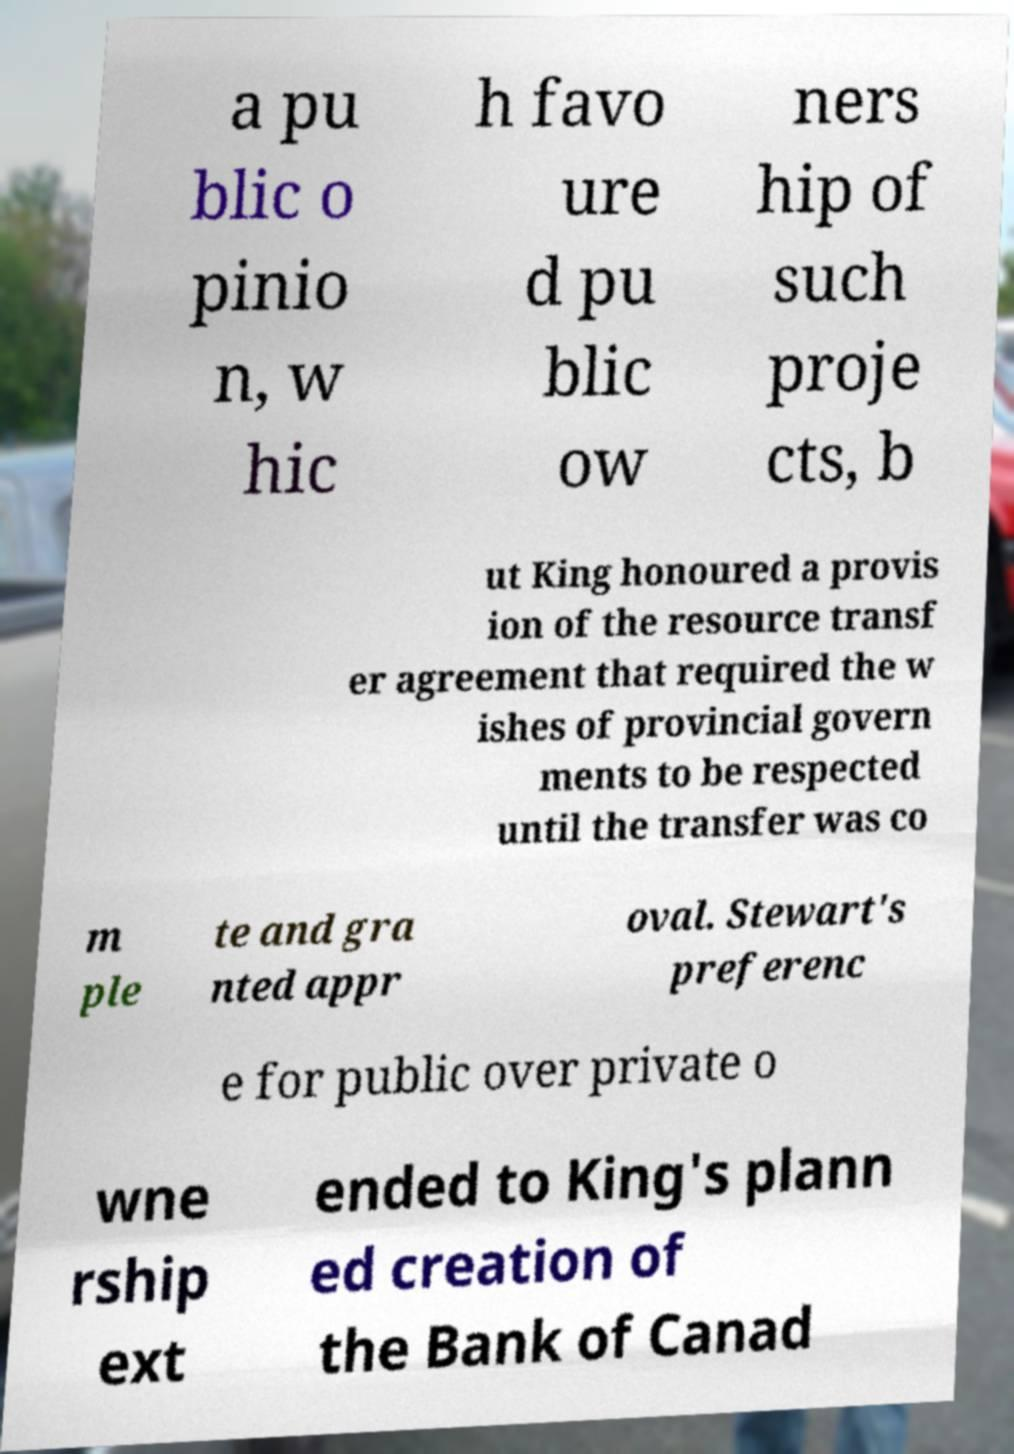Please read and relay the text visible in this image. What does it say? a pu blic o pinio n, w hic h favo ure d pu blic ow ners hip of such proje cts, b ut King honoured a provis ion of the resource transf er agreement that required the w ishes of provincial govern ments to be respected until the transfer was co m ple te and gra nted appr oval. Stewart's preferenc e for public over private o wne rship ext ended to King's plann ed creation of the Bank of Canad 